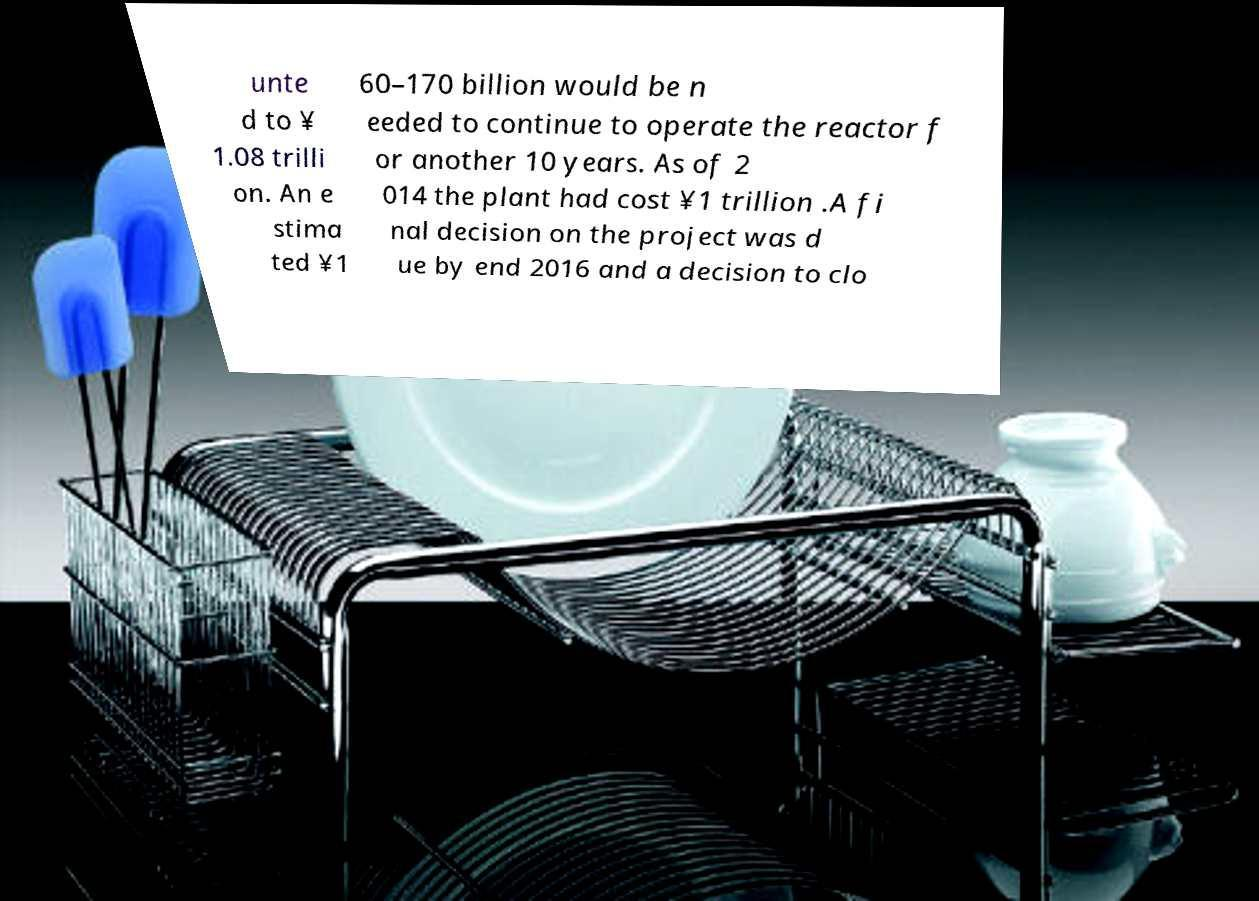There's text embedded in this image that I need extracted. Can you transcribe it verbatim? unte d to ¥ 1.08 trilli on. An e stima ted ¥1 60–170 billion would be n eeded to continue to operate the reactor f or another 10 years. As of 2 014 the plant had cost ¥1 trillion .A fi nal decision on the project was d ue by end 2016 and a decision to clo 